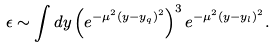Convert formula to latex. <formula><loc_0><loc_0><loc_500><loc_500>\epsilon \sim \int d y \left ( e ^ { - \mu ^ { 2 } ( y - y _ { q } ) ^ { 2 } } \right ) ^ { 3 } e ^ { - \mu ^ { 2 } ( y - y _ { l } ) ^ { 2 } } .</formula> 